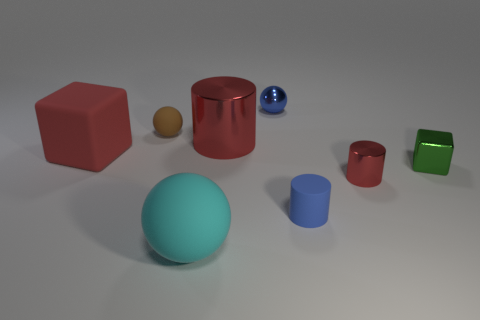How many other objects are there of the same size as the brown thing?
Your answer should be very brief. 4. Are there any red metallic objects of the same size as the green metallic object?
Give a very brief answer. Yes. Does the rubber ball in front of the tiny brown sphere have the same size as the red cylinder that is behind the small red shiny cylinder?
Give a very brief answer. Yes. What is the shape of the metallic object behind the matte ball that is behind the green object?
Offer a very short reply. Sphere. How many big blocks are in front of the blue cylinder?
Give a very brief answer. 0. What is the color of the big cube that is made of the same material as the cyan sphere?
Keep it short and to the point. Red. Is the size of the rubber cylinder the same as the object in front of the blue matte object?
Give a very brief answer. No. How big is the red object that is to the right of the small cylinder in front of the red metal cylinder that is in front of the small green block?
Your response must be concise. Small. What number of shiny objects are either small balls or red cylinders?
Your answer should be very brief. 3. What is the color of the block that is to the right of the blue shiny thing?
Your answer should be compact. Green. 